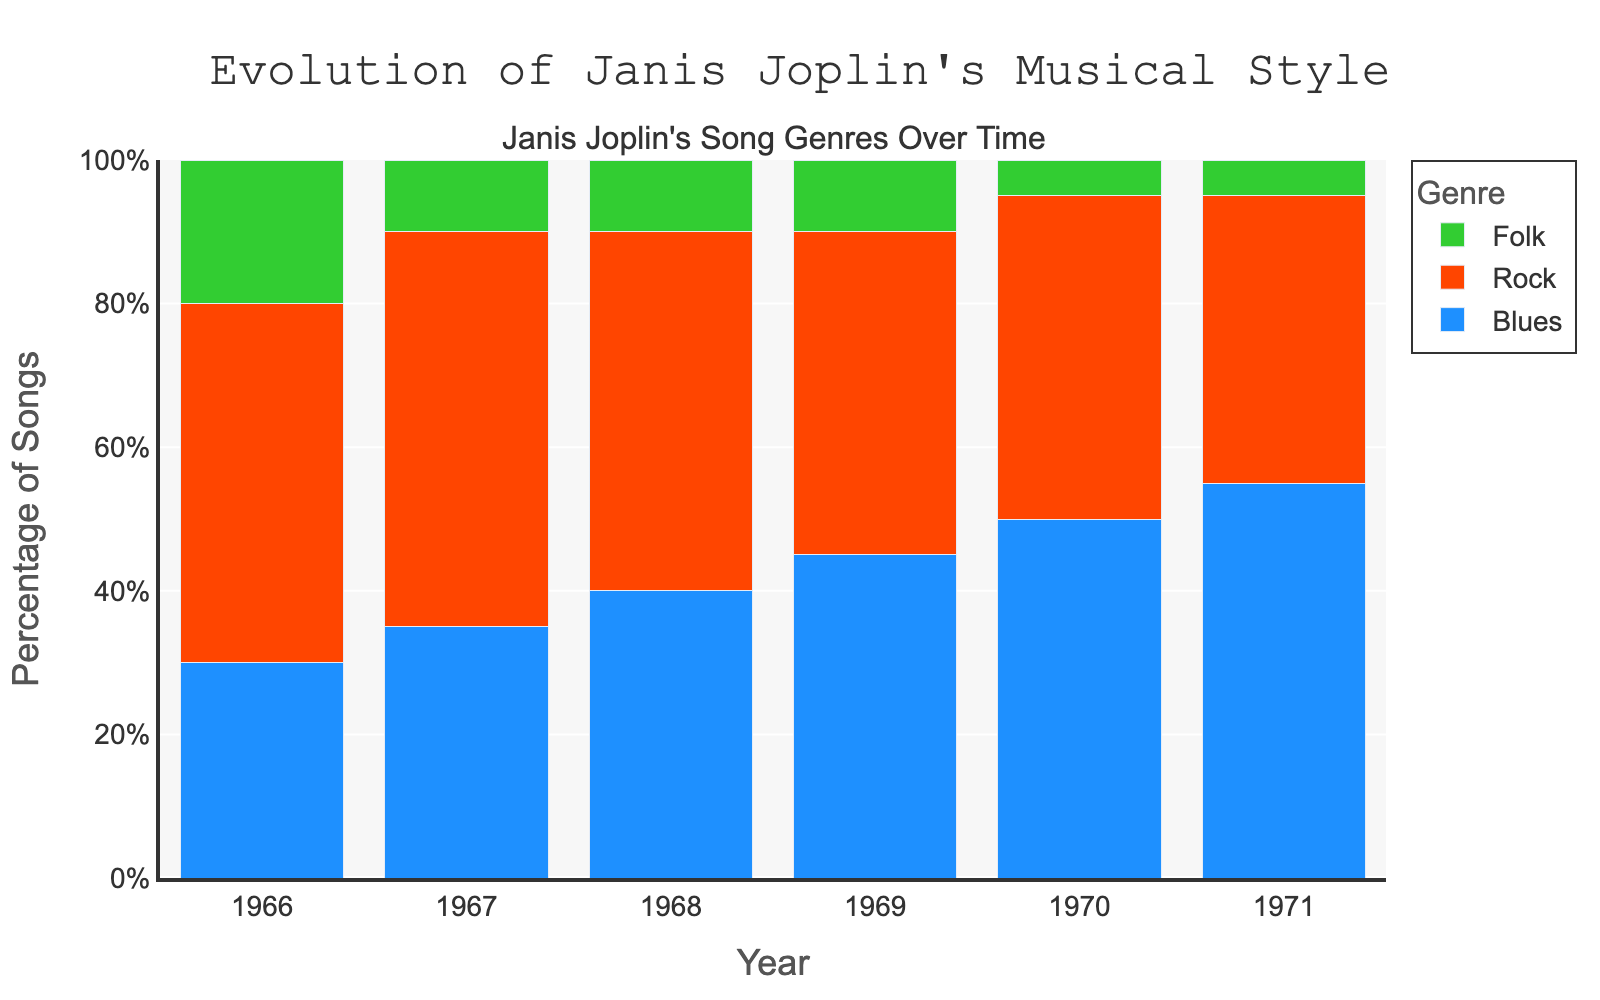Which year had the highest percentage of blues-influenced songs? The bar representing blues-influenced songs is tallest for the year 1971, indicating the highest percentage in that year.
Answer: 1971 How did the percentage of folk-influenced songs change from 1966 to 1971? In 1966, the percentage was 20%. By 1971, it decreased to 5%. This is a decrease of 15%.
Answer: Decreased by 15% What is the average percentage of rock-influenced songs from 1966 to 1971? Sum the percentages of rock for each year (50+55+50+45+45+40) and divide by the number of years (6). The sum is 285 and the average is 285/6.
Answer: 47.5% What is the trend in the percentage of blues-influenced songs from 1966 to 1971? The blues-influenced songs show an increasing trend. Starting from 30% in 1966, the percentage grows each year up to 55% in 1971.
Answer: Increasing In 1970, what is the combined percentage of songs influenced by genres other than rock? The percentage of blues-influenced songs is 50%, and folk is 5%. Adding these together gives 55%.
Answer: 55% In which year did folk-influenced songs have the smallest share? The shortest bar representing folk-influenced songs is in 1970 and 1971, both at 5%.
Answer: 1970, 1971 